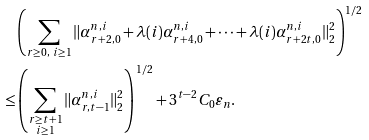Convert formula to latex. <formula><loc_0><loc_0><loc_500><loc_500>& \left ( \sum _ { \substack { r \geq 0 , \ i \geq 1 } } \| \alpha ^ { n , i } _ { r + 2 , 0 } + \lambda ( i ) \alpha ^ { n , i } _ { r + 4 , 0 } + \dots + \lambda ( i ) \alpha ^ { n , i } _ { r + 2 t , 0 } \| _ { 2 } ^ { 2 } \right ) ^ { 1 / 2 } \\ \leq & \left ( \sum _ { \substack { r \geq t + 1 \\ i \geq 1 } } \| \alpha ^ { n , i } _ { r , t - 1 } \| _ { 2 } ^ { 2 } \right ) ^ { 1 / 2 } + 3 ^ { t - 2 } C _ { 0 } \varepsilon _ { n } .</formula> 